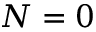Convert formula to latex. <formula><loc_0><loc_0><loc_500><loc_500>N = 0</formula> 